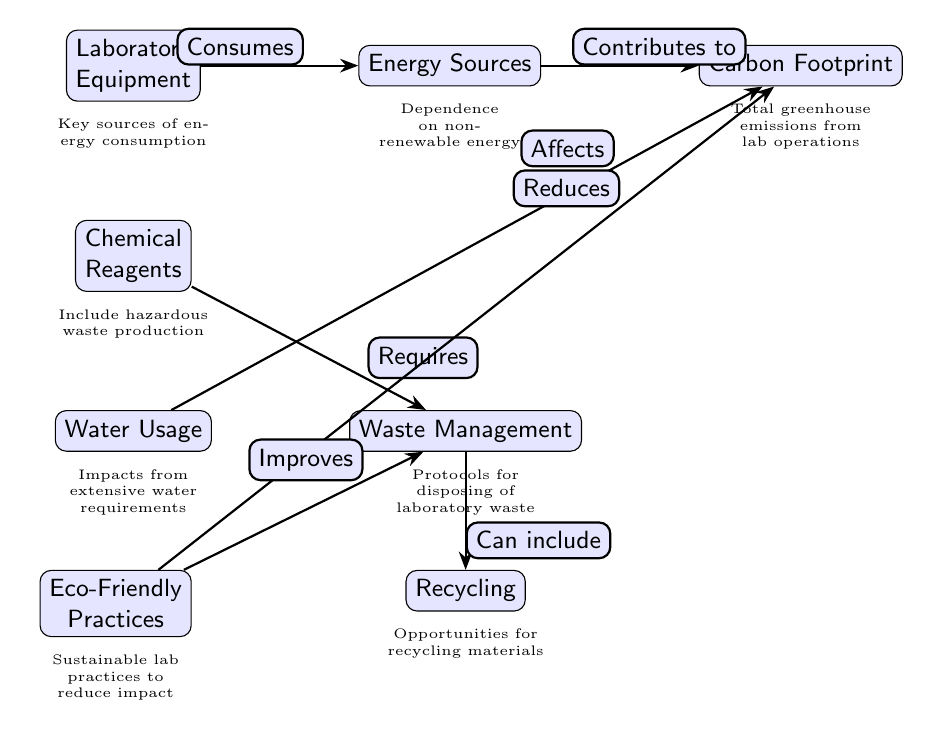What are the two main components that affect the Carbon Footprint? The diagram indicates that both Energy Sources and Water Usage contribute to the Carbon Footprint based on their connections.
Answer: Energy Sources and Water Usage How many nodes are present in the diagram? By counting the distinct labeled nodes in the diagram, we identify the nodes: Laboratory Equipment, Chemical Reagents, Water Usage, Energy Sources, Carbon Footprint, Waste Management, Recycling, and Eco-Friendly Practices, totaling eight nodes.
Answer: 8 What does Waste Management include? The diagram states that Waste Management can include Recycling, indicated by the directional edge leading directly to the Recycling node.
Answer: Recycling Which element directly contributes to the Carbon Footprint? The arrow from Energy Sources towards Carbon Footprint shows that Energy Sources directly contribute to the Carbon Footprint as labeled on the edge.
Answer: Energy Sources What improves Waste Management according to the diagram? The diagram specifies that Eco-Friendly Practices improve Waste Management based on the direct connection represented by the arrow pointing from Eco-Friendly Practices to Waste Management.
Answer: Eco-Friendly Practices How many edges are there in total within the diagram? By tracing the arrows connecting the nodes, we can observe that there are seven directed edges indicating relationships between the various components.
Answer: 7 Which node requires Waste Management? The relationship displayed in the diagram indicates that Chemical Reagents require Waste Management, as shown by the edge leading from Chemicals to Waste Management.
Answer: Chemical Reagents What effect does Water Usage have on Carbon Footprint? The diagram indicates that Water Usage affects the Carbon Footprint, as depicted by the edge that connects Water Usage to Carbon Footprint, showing a direct interaction.
Answer: Affects 